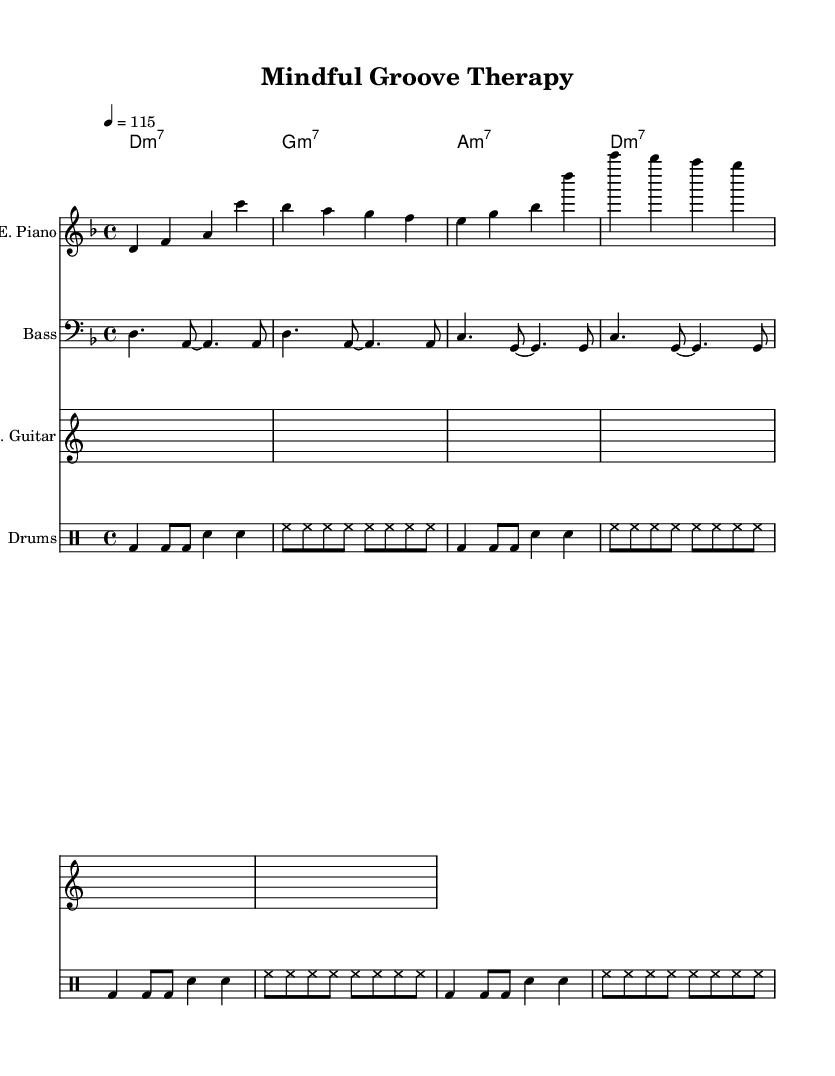What is the key signature of this music? The key signature is D minor, which includes one flat (B flat). This can be determined by looking at the key signature just after the clef symbol at the beginning of the staff.
Answer: D minor What is the time signature of this music? The time signature is 4/4, which means there are four beats in each measure. This is evident from the notation placed at the beginning of the score, indicating the number of beats per measure and the note that gets one beat.
Answer: 4/4 What is the tempo marking of this music? The tempo marking indicates a speed of 115 beats per minute, which can be found near the beginning of the score. It shows that the piece should be played at a moderate pace.
Answer: 115 How many measures are there in the electric piano part? The electric piano part contains 8 measures, which can be counted directly from the music notation provided. Each group of notes separated by vertical lines represents a measure.
Answer: 8 Which chord is played at the beginning of the piece? The chord played at the beginning of the piece is D minor 7. This is found in the chord names section, located above the staves, indicating the harmony that accompanies the melody.
Answer: D minor 7 What rhythmic pattern is primarily used in the drum part? The primary rhythmic pattern in the drum part consists of bass drum and snare hits along with a consistent hi-hat rhythm. The patterns repeat, indicating a steady disco beat essential for the dance genre.
Answer: Disco beat What instruments are featured in this score? The instruments featured in this score are Electric Piano, Bass, Rhythm Guitar, and Drums. These are labeled at the beginning of their respective staves in the sheet music.
Answer: Electric Piano, Bass, Rhythm Guitar, Drums 